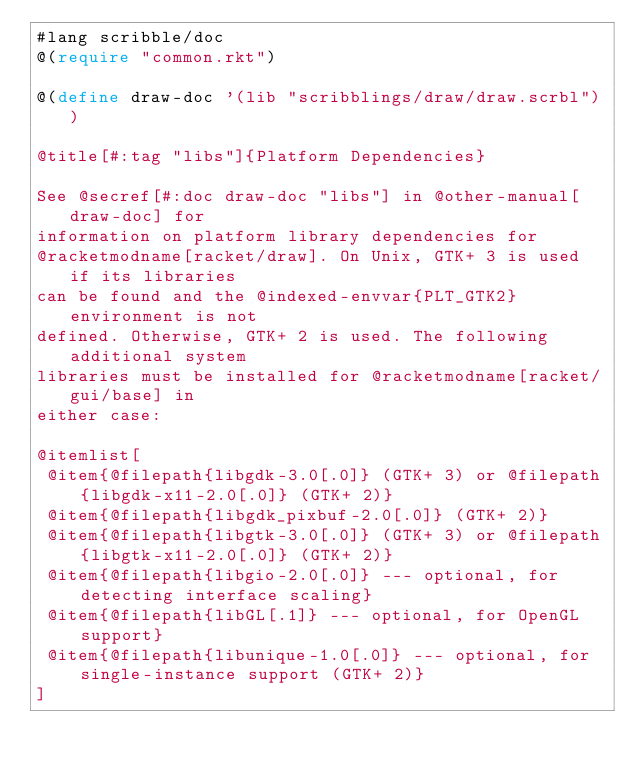Convert code to text. <code><loc_0><loc_0><loc_500><loc_500><_Racket_>#lang scribble/doc
@(require "common.rkt")

@(define draw-doc '(lib "scribblings/draw/draw.scrbl"))

@title[#:tag "libs"]{Platform Dependencies}

See @secref[#:doc draw-doc "libs"] in @other-manual[draw-doc] for
information on platform library dependencies for
@racketmodname[racket/draw]. On Unix, GTK+ 3 is used if its libraries
can be found and the @indexed-envvar{PLT_GTK2} environment is not
defined. Otherwise, GTK+ 2 is used. The following additional system
libraries must be installed for @racketmodname[racket/gui/base] in
either case:

@itemlist[
 @item{@filepath{libgdk-3.0[.0]} (GTK+ 3) or @filepath{libgdk-x11-2.0[.0]} (GTK+ 2)}
 @item{@filepath{libgdk_pixbuf-2.0[.0]} (GTK+ 2)}
 @item{@filepath{libgtk-3.0[.0]} (GTK+ 3) or @filepath{libgtk-x11-2.0[.0]} (GTK+ 2)}
 @item{@filepath{libgio-2.0[.0]} --- optional, for detecting interface scaling}
 @item{@filepath{libGL[.1]} --- optional, for OpenGL support}
 @item{@filepath{libunique-1.0[.0]} --- optional, for single-instance support (GTK+ 2)}
]
</code> 